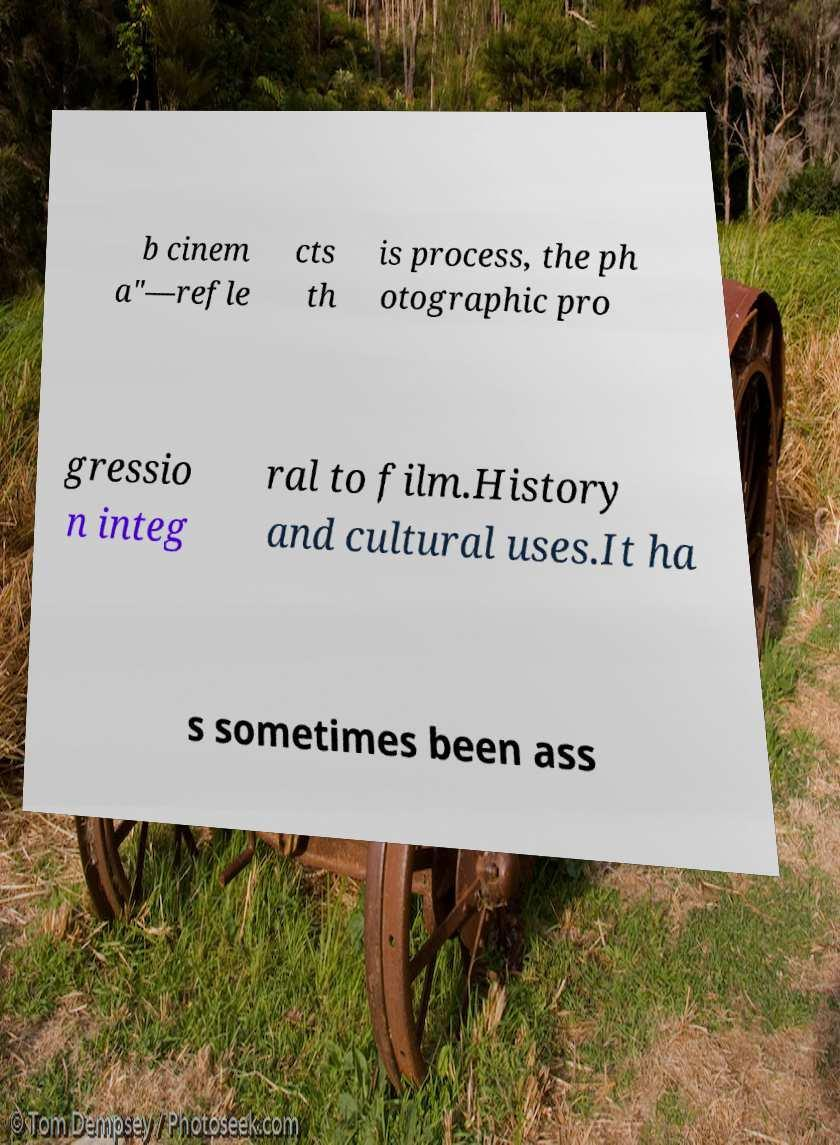For documentation purposes, I need the text within this image transcribed. Could you provide that? b cinem a"—refle cts th is process, the ph otographic pro gressio n integ ral to film.History and cultural uses.It ha s sometimes been ass 